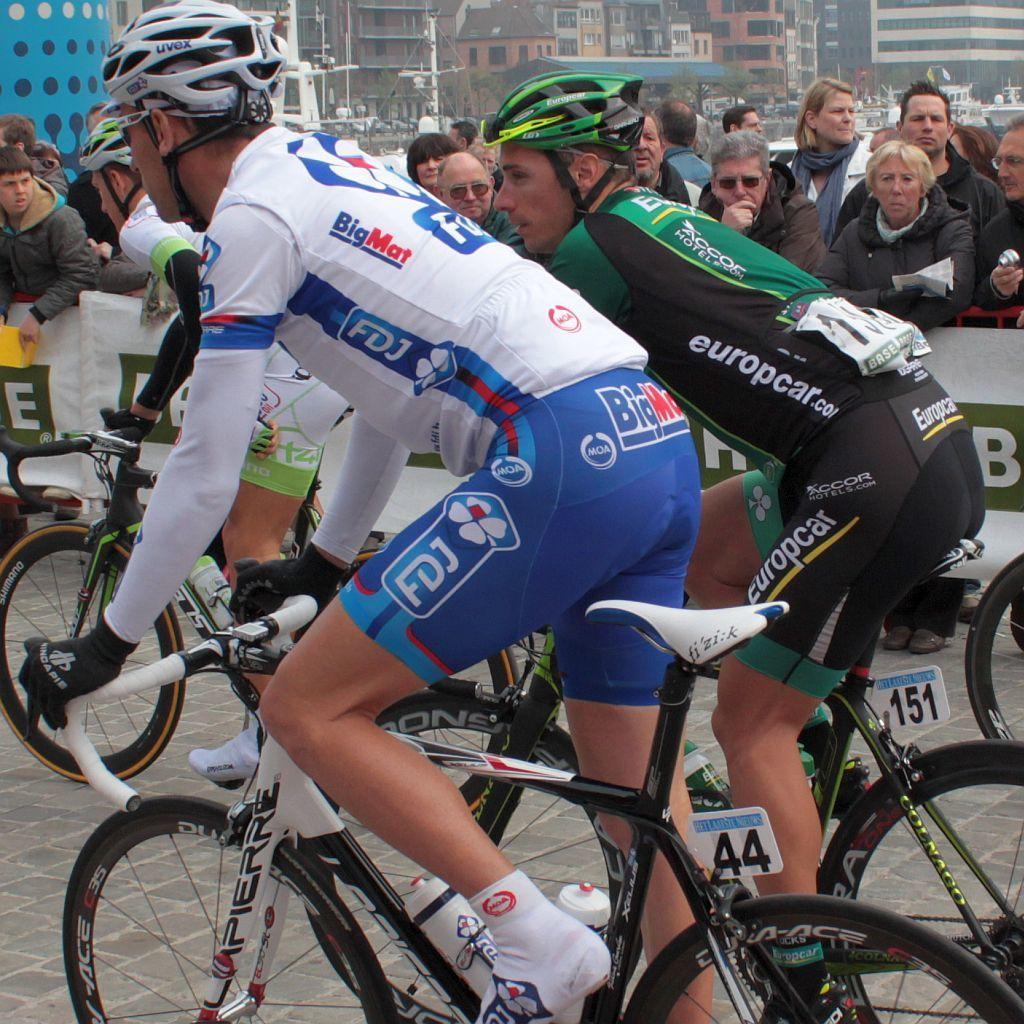Could you give a brief overview of what you see in this image? on the background we can see buildings. How we can see few persons riding bicycles wearing helmets. We can see crowd over here. 